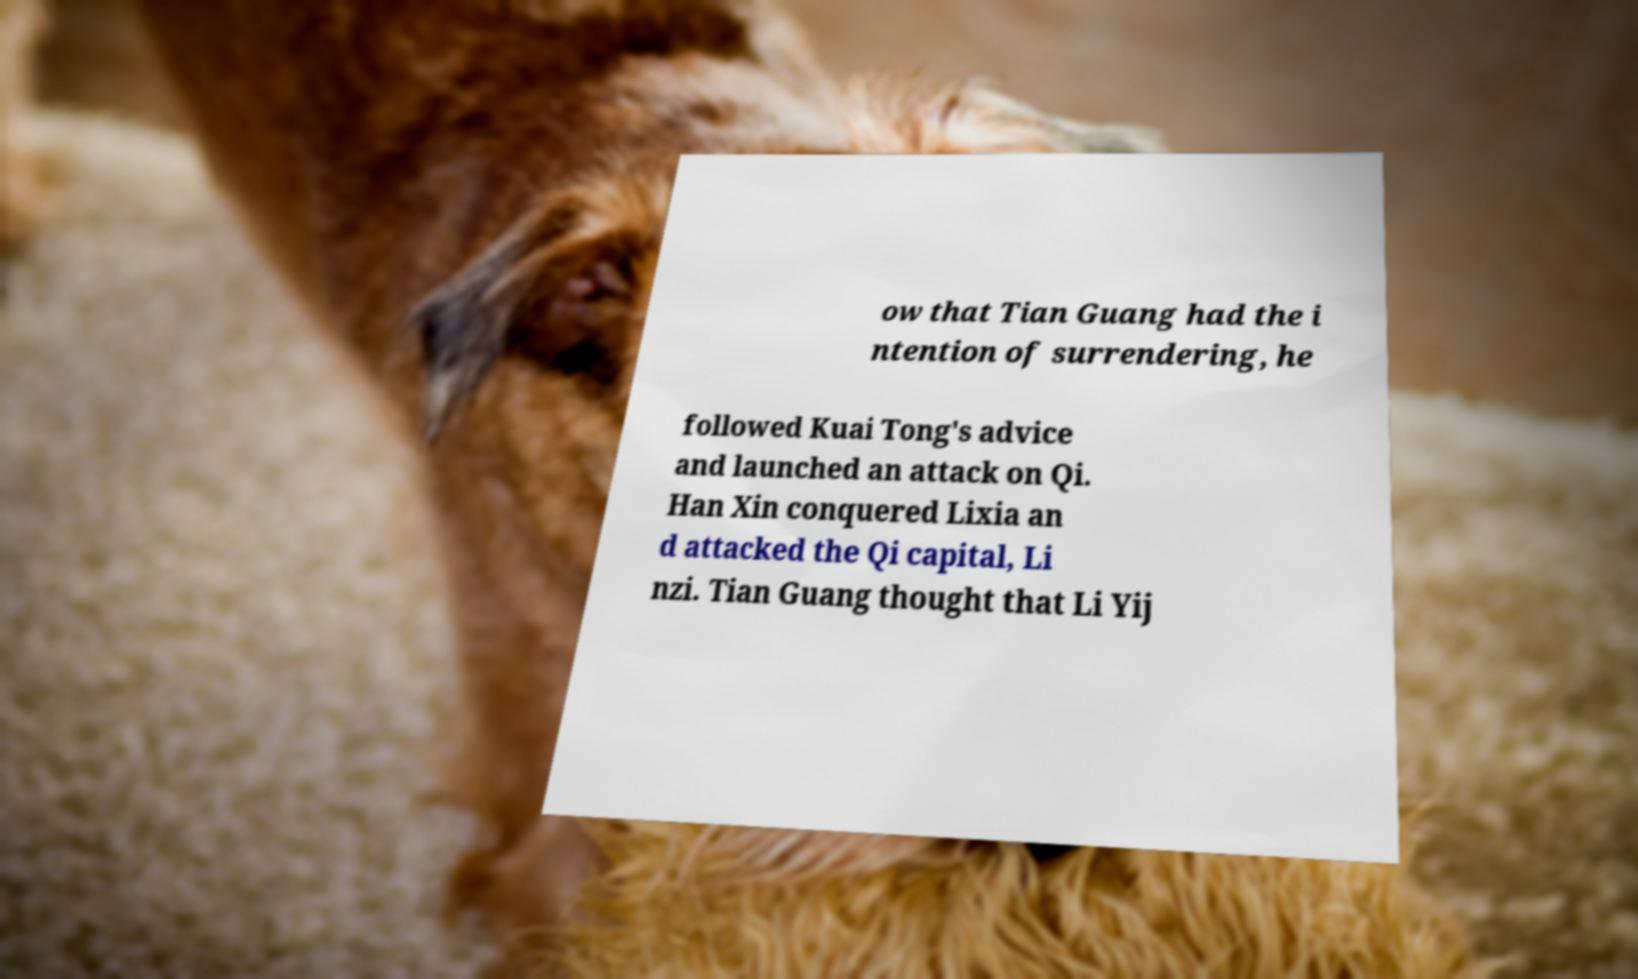Could you extract and type out the text from this image? ow that Tian Guang had the i ntention of surrendering, he followed Kuai Tong's advice and launched an attack on Qi. Han Xin conquered Lixia an d attacked the Qi capital, Li nzi. Tian Guang thought that Li Yij 